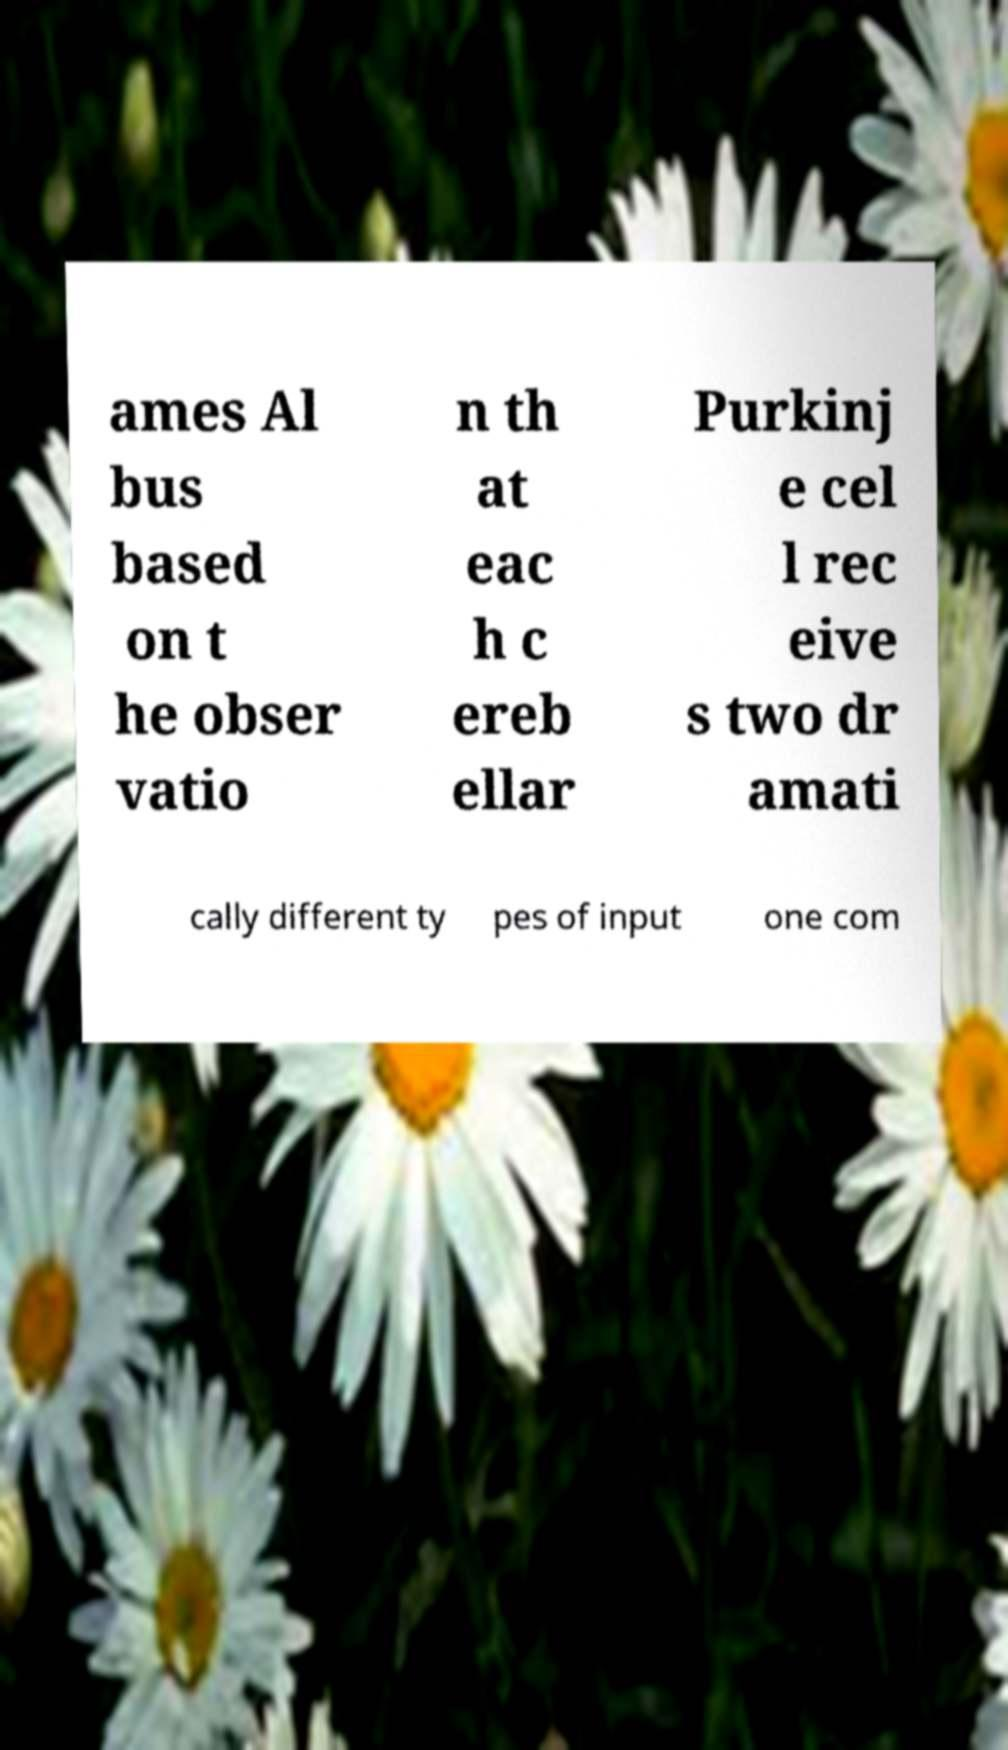Please identify and transcribe the text found in this image. ames Al bus based on t he obser vatio n th at eac h c ereb ellar Purkinj e cel l rec eive s two dr amati cally different ty pes of input one com 